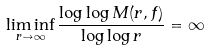<formula> <loc_0><loc_0><loc_500><loc_500>\liminf _ { r \to \infty } \frac { \log \log M ( r , f ) } { \log \log r } = \infty</formula> 